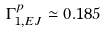Convert formula to latex. <formula><loc_0><loc_0><loc_500><loc_500>\Gamma _ { 1 , E J } ^ { p } \simeq 0 . 1 8 5</formula> 